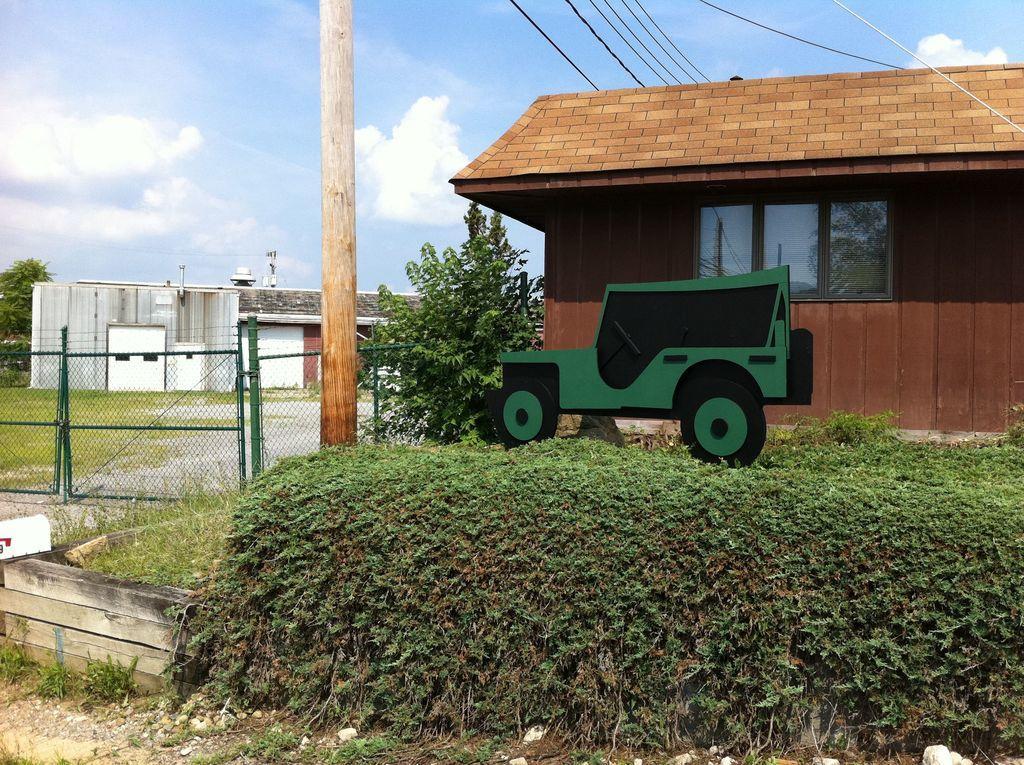Please provide a concise description of this image. In the foreground of the picture there are plants, railing, pole and various objects. In the middle of the picture there are buildings. At the top there are cables and sky. 